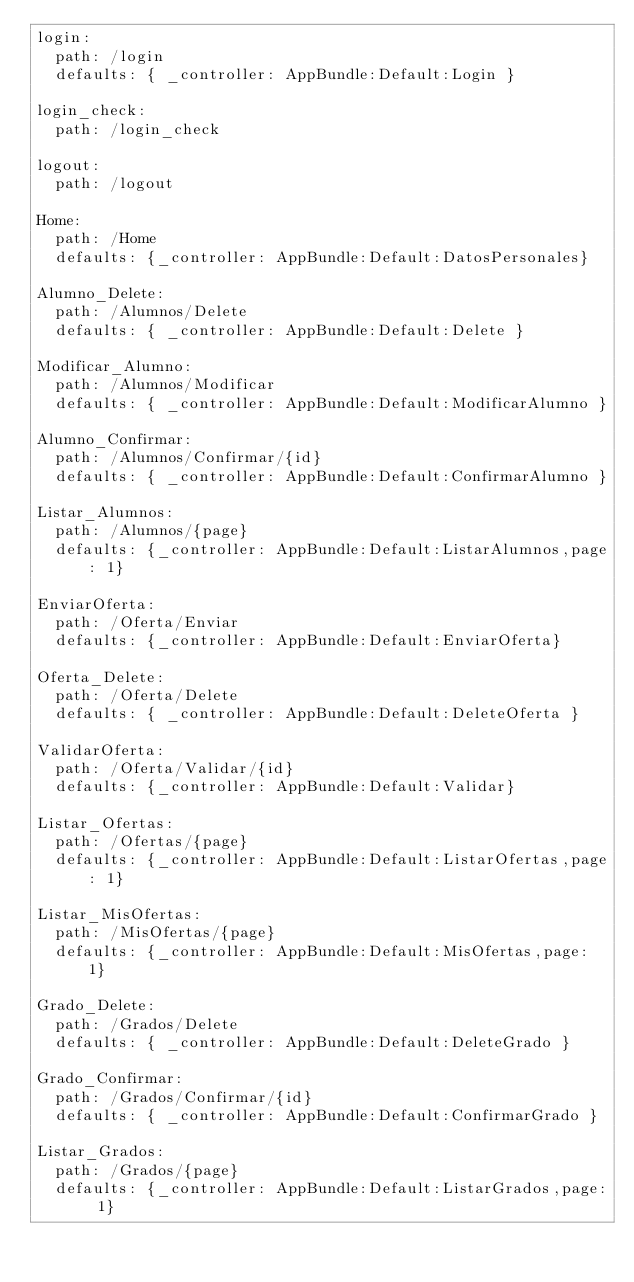<code> <loc_0><loc_0><loc_500><loc_500><_YAML_>login:
  path: /login
  defaults: { _controller: AppBundle:Default:Login }

login_check:
  path: /login_check

logout:
  path: /logout
  
Home:
  path: /Home
  defaults: {_controller: AppBundle:Default:DatosPersonales}

Alumno_Delete:
  path: /Alumnos/Delete
  defaults: { _controller: AppBundle:Default:Delete }

Modificar_Alumno:
  path: /Alumnos/Modificar
  defaults: { _controller: AppBundle:Default:ModificarAlumno }

Alumno_Confirmar:
  path: /Alumnos/Confirmar/{id}
  defaults: { _controller: AppBundle:Default:ConfirmarAlumno }

Listar_Alumnos:
  path: /Alumnos/{page}
  defaults: {_controller: AppBundle:Default:ListarAlumnos,page: 1}

EnviarOferta:
  path: /Oferta/Enviar
  defaults: {_controller: AppBundle:Default:EnviarOferta}

Oferta_Delete:
  path: /Oferta/Delete
  defaults: { _controller: AppBundle:Default:DeleteOferta }

ValidarOferta:
  path: /Oferta/Validar/{id}
  defaults: {_controller: AppBundle:Default:Validar}

Listar_Ofertas:
  path: /Ofertas/{page}
  defaults: {_controller: AppBundle:Default:ListarOfertas,page: 1}

Listar_MisOfertas:
  path: /MisOfertas/{page}
  defaults: {_controller: AppBundle:Default:MisOfertas,page: 1}

Grado_Delete:
  path: /Grados/Delete
  defaults: { _controller: AppBundle:Default:DeleteGrado }

Grado_Confirmar:
  path: /Grados/Confirmar/{id}
  defaults: { _controller: AppBundle:Default:ConfirmarGrado }

Listar_Grados:
  path: /Grados/{page}
  defaults: {_controller: AppBundle:Default:ListarGrados,page: 1}






</code> 